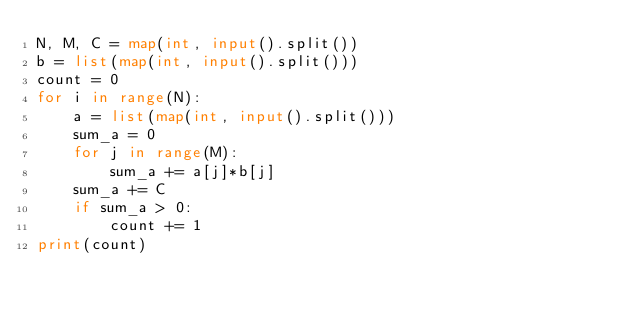Convert code to text. <code><loc_0><loc_0><loc_500><loc_500><_Python_>N, M, C = map(int, input().split())
b = list(map(int, input().split()))
count = 0
for i in range(N):
    a = list(map(int, input().split()))
    sum_a = 0
    for j in range(M):
        sum_a += a[j]*b[j]
    sum_a += C
    if sum_a > 0:
        count += 1
print(count)</code> 